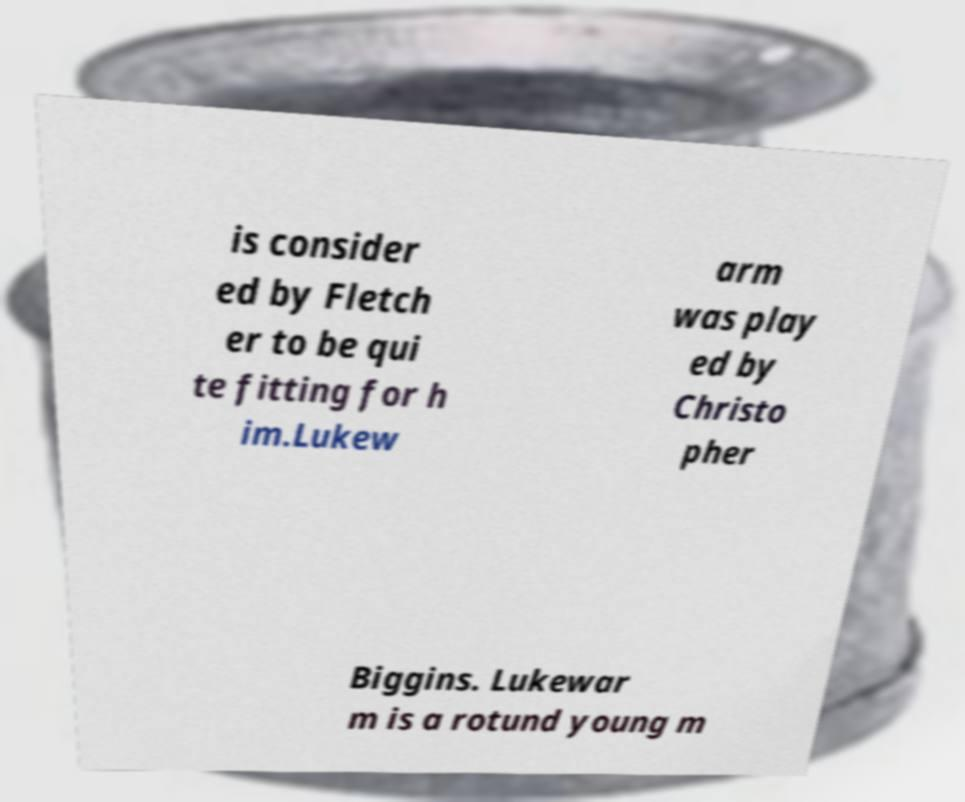Please read and relay the text visible in this image. What does it say? is consider ed by Fletch er to be qui te fitting for h im.Lukew arm was play ed by Christo pher Biggins. Lukewar m is a rotund young m 